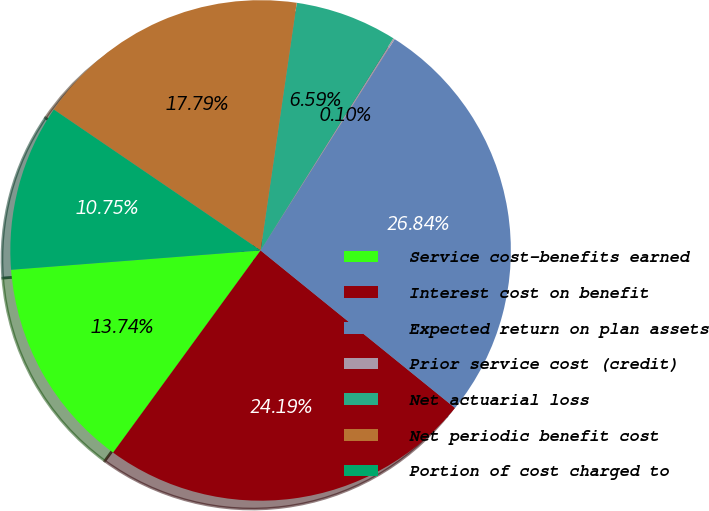<chart> <loc_0><loc_0><loc_500><loc_500><pie_chart><fcel>Service cost-benefits earned<fcel>Interest cost on benefit<fcel>Expected return on plan assets<fcel>Prior service cost (credit)<fcel>Net actuarial loss<fcel>Net periodic benefit cost<fcel>Portion of cost charged to<nl><fcel>13.74%<fcel>24.19%<fcel>26.84%<fcel>0.1%<fcel>6.59%<fcel>17.79%<fcel>10.75%<nl></chart> 